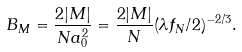Convert formula to latex. <formula><loc_0><loc_0><loc_500><loc_500>B _ { M } = \frac { 2 | M | } { N a _ { 0 } ^ { 2 } } = \frac { 2 | M | } { N } ( \lambda f _ { N } / 2 ) ^ { - 2 / 3 } .</formula> 